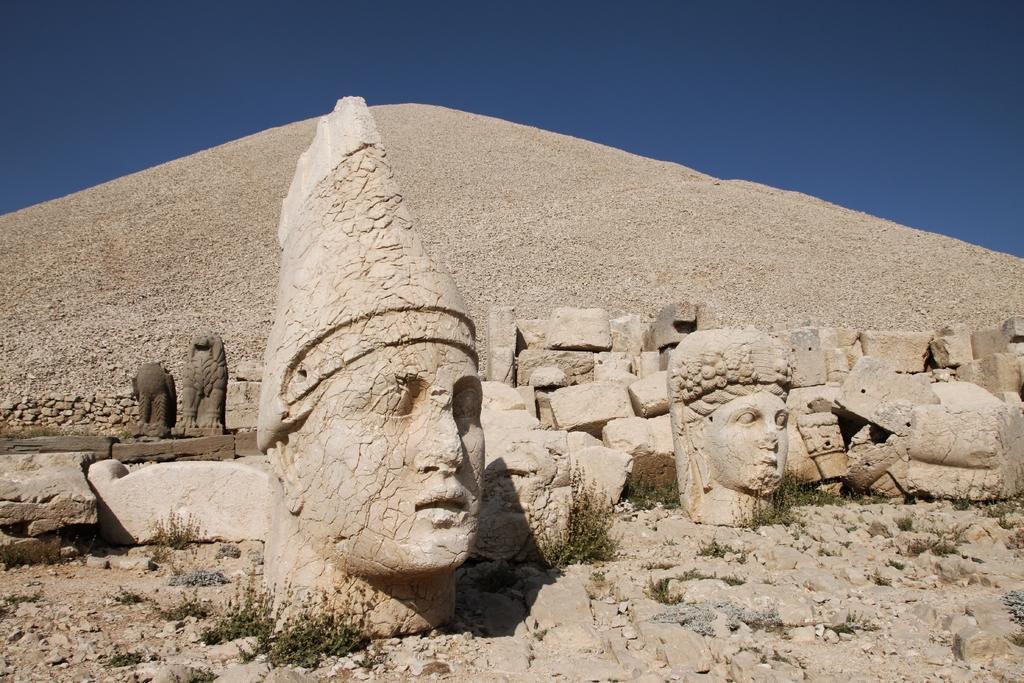How would you summarize this image in a sentence or two? At the bottom of the image there are some sculptures. Behind them there is a pyramid. At the top of the image there is sky. 